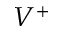Convert formula to latex. <formula><loc_0><loc_0><loc_500><loc_500>V ^ { + }</formula> 